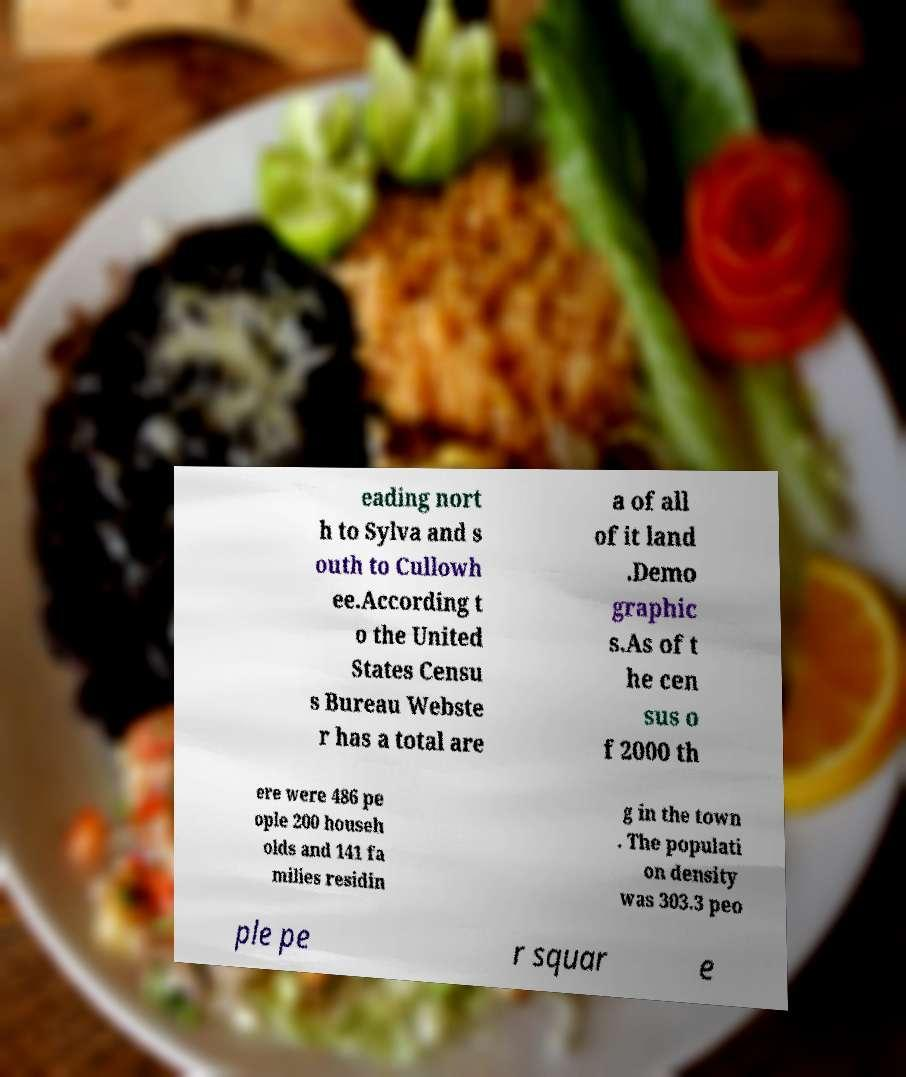Could you extract and type out the text from this image? eading nort h to Sylva and s outh to Cullowh ee.According t o the United States Censu s Bureau Webste r has a total are a of all of it land .Demo graphic s.As of t he cen sus o f 2000 th ere were 486 pe ople 200 househ olds and 141 fa milies residin g in the town . The populati on density was 303.3 peo ple pe r squar e 